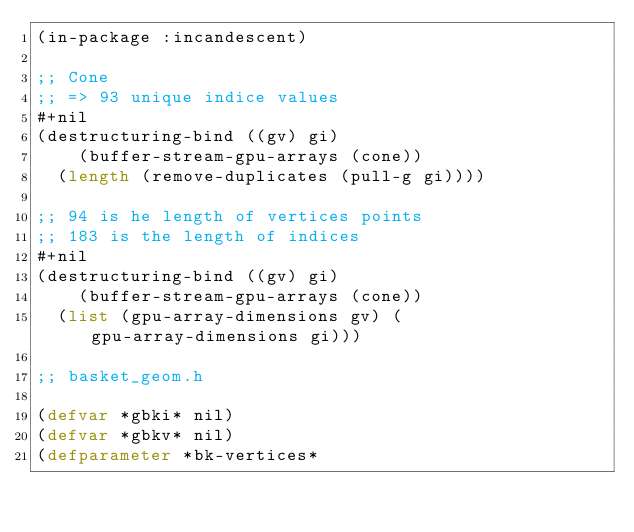<code> <loc_0><loc_0><loc_500><loc_500><_Lisp_>(in-package :incandescent)

;; Cone
;; => 93 unique indice values
#+nil
(destructuring-bind ((gv) gi)
    (buffer-stream-gpu-arrays (cone))
  (length (remove-duplicates (pull-g gi))))

;; 94 is he length of vertices points
;; 183 is the length of indices
#+nil
(destructuring-bind ((gv) gi)
    (buffer-stream-gpu-arrays (cone))
  (list (gpu-array-dimensions gv) (gpu-array-dimensions gi)))

;; basket_geom.h

(defvar *gbki* nil)
(defvar *gbkv* nil)
(defparameter *bk-vertices*</code> 